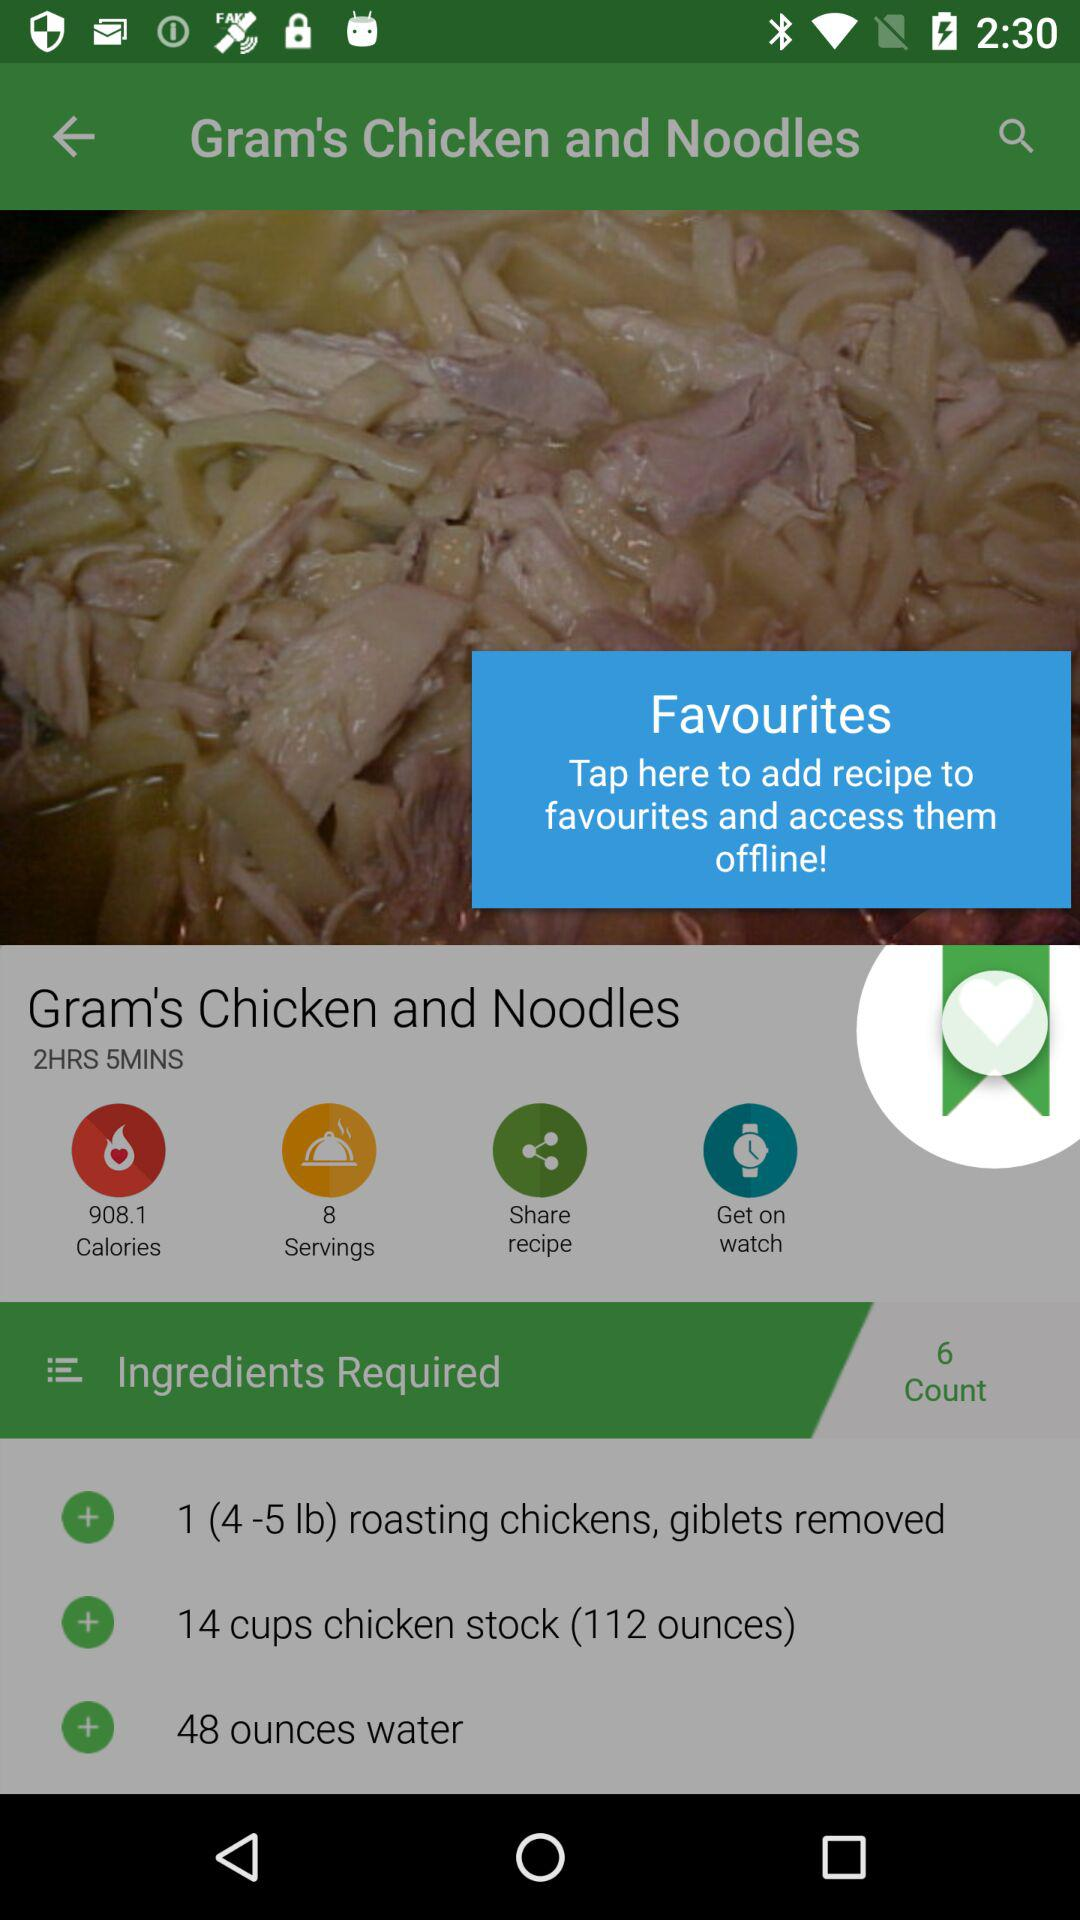What are the ingredients required? The ingredients required are 1 (4-5 lb) roasted chicken with giblets removed, 14 cups of chicken stock (112 ounces) and 48 ounces of water. 